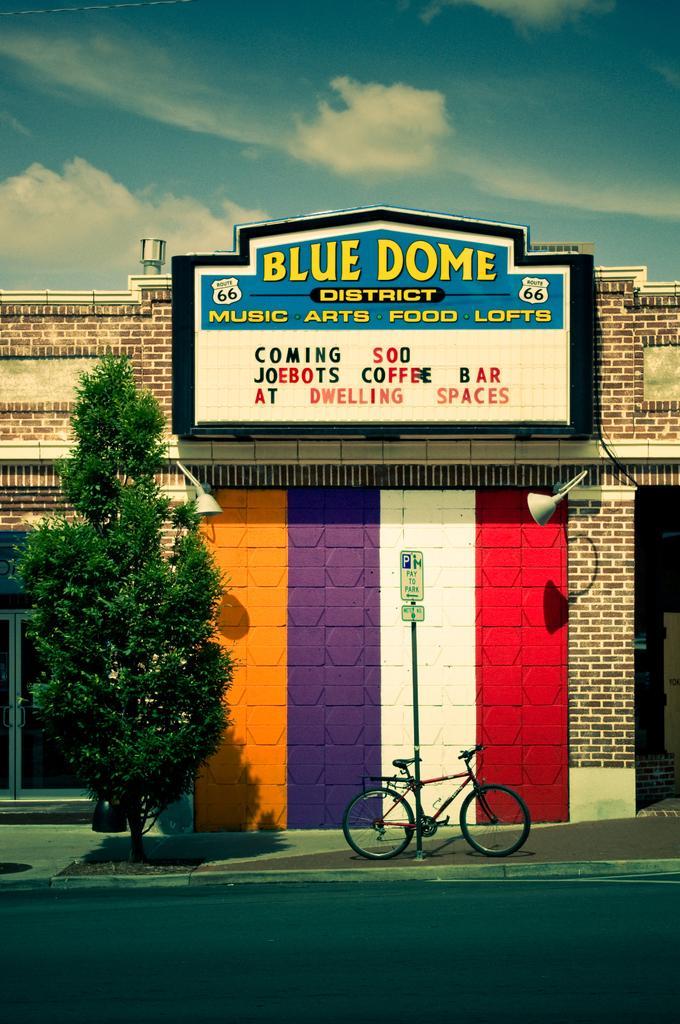Describe this image in one or two sentences. In this image I can see a building which is yellow, violet, white, red and brown in color. I can see the sidewalk on which I can see a tree, a bicycle and a pole. I can see a huge board to the building and in the background I can see the sky. In the background I can see the sky. 